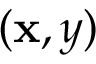<formula> <loc_0><loc_0><loc_500><loc_500>( x , y )</formula> 